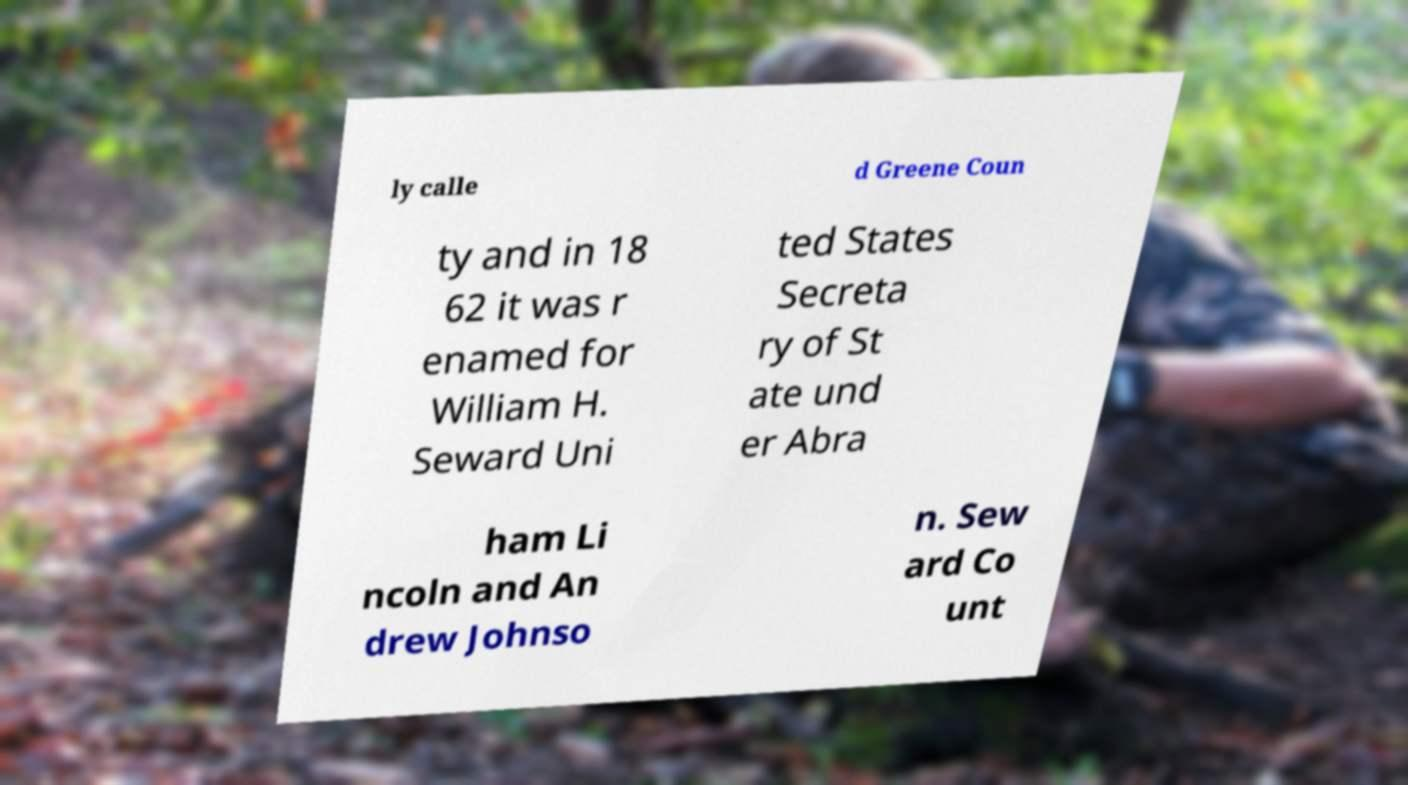Please read and relay the text visible in this image. What does it say? ly calle d Greene Coun ty and in 18 62 it was r enamed for William H. Seward Uni ted States Secreta ry of St ate und er Abra ham Li ncoln and An drew Johnso n. Sew ard Co unt 